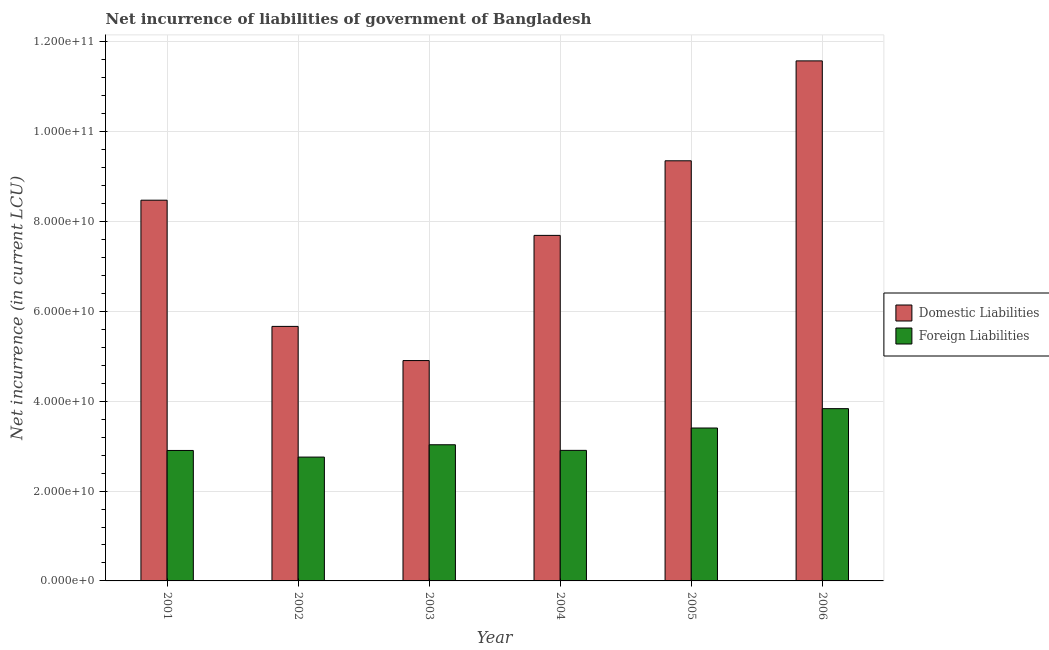How many different coloured bars are there?
Your answer should be compact. 2. How many bars are there on the 4th tick from the left?
Provide a short and direct response. 2. How many bars are there on the 4th tick from the right?
Ensure brevity in your answer.  2. What is the label of the 4th group of bars from the left?
Provide a short and direct response. 2004. In how many cases, is the number of bars for a given year not equal to the number of legend labels?
Keep it short and to the point. 0. What is the net incurrence of foreign liabilities in 2004?
Provide a succinct answer. 2.91e+1. Across all years, what is the maximum net incurrence of domestic liabilities?
Your answer should be compact. 1.16e+11. Across all years, what is the minimum net incurrence of domestic liabilities?
Give a very brief answer. 4.91e+1. What is the total net incurrence of foreign liabilities in the graph?
Offer a terse response. 1.88e+11. What is the difference between the net incurrence of foreign liabilities in 2002 and that in 2005?
Offer a very short reply. -6.47e+09. What is the difference between the net incurrence of domestic liabilities in 2001 and the net incurrence of foreign liabilities in 2006?
Make the answer very short. -3.10e+1. What is the average net incurrence of foreign liabilities per year?
Offer a very short reply. 3.14e+1. In how many years, is the net incurrence of domestic liabilities greater than 72000000000 LCU?
Provide a succinct answer. 4. What is the ratio of the net incurrence of foreign liabilities in 2002 to that in 2004?
Give a very brief answer. 0.95. Is the net incurrence of domestic liabilities in 2001 less than that in 2006?
Your answer should be very brief. Yes. What is the difference between the highest and the second highest net incurrence of foreign liabilities?
Provide a succinct answer. 4.31e+09. What is the difference between the highest and the lowest net incurrence of foreign liabilities?
Ensure brevity in your answer.  1.08e+1. What does the 1st bar from the left in 2001 represents?
Your answer should be very brief. Domestic Liabilities. What does the 2nd bar from the right in 2001 represents?
Make the answer very short. Domestic Liabilities. How many bars are there?
Offer a terse response. 12. Are the values on the major ticks of Y-axis written in scientific E-notation?
Provide a succinct answer. Yes. Does the graph contain any zero values?
Make the answer very short. No. How many legend labels are there?
Make the answer very short. 2. What is the title of the graph?
Your answer should be very brief. Net incurrence of liabilities of government of Bangladesh. Does "Mineral" appear as one of the legend labels in the graph?
Provide a short and direct response. No. What is the label or title of the Y-axis?
Keep it short and to the point. Net incurrence (in current LCU). What is the Net incurrence (in current LCU) of Domestic Liabilities in 2001?
Ensure brevity in your answer.  8.47e+1. What is the Net incurrence (in current LCU) of Foreign Liabilities in 2001?
Provide a short and direct response. 2.90e+1. What is the Net incurrence (in current LCU) in Domestic Liabilities in 2002?
Your answer should be compact. 5.67e+1. What is the Net incurrence (in current LCU) in Foreign Liabilities in 2002?
Provide a short and direct response. 2.76e+1. What is the Net incurrence (in current LCU) in Domestic Liabilities in 2003?
Your answer should be very brief. 4.91e+1. What is the Net incurrence (in current LCU) in Foreign Liabilities in 2003?
Your answer should be very brief. 3.03e+1. What is the Net incurrence (in current LCU) in Domestic Liabilities in 2004?
Your answer should be compact. 7.69e+1. What is the Net incurrence (in current LCU) of Foreign Liabilities in 2004?
Provide a short and direct response. 2.91e+1. What is the Net incurrence (in current LCU) in Domestic Liabilities in 2005?
Your answer should be compact. 9.35e+1. What is the Net incurrence (in current LCU) of Foreign Liabilities in 2005?
Offer a very short reply. 3.40e+1. What is the Net incurrence (in current LCU) in Domestic Liabilities in 2006?
Keep it short and to the point. 1.16e+11. What is the Net incurrence (in current LCU) in Foreign Liabilities in 2006?
Provide a short and direct response. 3.83e+1. Across all years, what is the maximum Net incurrence (in current LCU) in Domestic Liabilities?
Offer a very short reply. 1.16e+11. Across all years, what is the maximum Net incurrence (in current LCU) in Foreign Liabilities?
Your answer should be very brief. 3.83e+1. Across all years, what is the minimum Net incurrence (in current LCU) of Domestic Liabilities?
Provide a succinct answer. 4.91e+1. Across all years, what is the minimum Net incurrence (in current LCU) in Foreign Liabilities?
Your answer should be compact. 2.76e+1. What is the total Net incurrence (in current LCU) of Domestic Liabilities in the graph?
Ensure brevity in your answer.  4.77e+11. What is the total Net incurrence (in current LCU) in Foreign Liabilities in the graph?
Ensure brevity in your answer.  1.88e+11. What is the difference between the Net incurrence (in current LCU) in Domestic Liabilities in 2001 and that in 2002?
Keep it short and to the point. 2.81e+1. What is the difference between the Net incurrence (in current LCU) of Foreign Liabilities in 2001 and that in 2002?
Offer a very short reply. 1.47e+09. What is the difference between the Net incurrence (in current LCU) of Domestic Liabilities in 2001 and that in 2003?
Provide a short and direct response. 3.57e+1. What is the difference between the Net incurrence (in current LCU) in Foreign Liabilities in 2001 and that in 2003?
Provide a short and direct response. -1.27e+09. What is the difference between the Net incurrence (in current LCU) in Domestic Liabilities in 2001 and that in 2004?
Your answer should be very brief. 7.83e+09. What is the difference between the Net incurrence (in current LCU) of Foreign Liabilities in 2001 and that in 2004?
Your answer should be very brief. -2.12e+07. What is the difference between the Net incurrence (in current LCU) of Domestic Liabilities in 2001 and that in 2005?
Offer a very short reply. -8.77e+09. What is the difference between the Net incurrence (in current LCU) of Foreign Liabilities in 2001 and that in 2005?
Your answer should be very brief. -5.00e+09. What is the difference between the Net incurrence (in current LCU) of Domestic Liabilities in 2001 and that in 2006?
Give a very brief answer. -3.10e+1. What is the difference between the Net incurrence (in current LCU) in Foreign Liabilities in 2001 and that in 2006?
Ensure brevity in your answer.  -9.31e+09. What is the difference between the Net incurrence (in current LCU) of Domestic Liabilities in 2002 and that in 2003?
Offer a very short reply. 7.60e+09. What is the difference between the Net incurrence (in current LCU) in Foreign Liabilities in 2002 and that in 2003?
Offer a terse response. -2.74e+09. What is the difference between the Net incurrence (in current LCU) of Domestic Liabilities in 2002 and that in 2004?
Provide a succinct answer. -2.03e+1. What is the difference between the Net incurrence (in current LCU) of Foreign Liabilities in 2002 and that in 2004?
Your answer should be very brief. -1.49e+09. What is the difference between the Net incurrence (in current LCU) of Domestic Liabilities in 2002 and that in 2005?
Your response must be concise. -3.69e+1. What is the difference between the Net incurrence (in current LCU) of Foreign Liabilities in 2002 and that in 2005?
Keep it short and to the point. -6.47e+09. What is the difference between the Net incurrence (in current LCU) of Domestic Liabilities in 2002 and that in 2006?
Keep it short and to the point. -5.91e+1. What is the difference between the Net incurrence (in current LCU) of Foreign Liabilities in 2002 and that in 2006?
Offer a very short reply. -1.08e+1. What is the difference between the Net incurrence (in current LCU) in Domestic Liabilities in 2003 and that in 2004?
Make the answer very short. -2.79e+1. What is the difference between the Net incurrence (in current LCU) in Foreign Liabilities in 2003 and that in 2004?
Your answer should be compact. 1.25e+09. What is the difference between the Net incurrence (in current LCU) in Domestic Liabilities in 2003 and that in 2005?
Provide a short and direct response. -4.45e+1. What is the difference between the Net incurrence (in current LCU) of Foreign Liabilities in 2003 and that in 2005?
Ensure brevity in your answer.  -3.73e+09. What is the difference between the Net incurrence (in current LCU) of Domestic Liabilities in 2003 and that in 2006?
Your answer should be very brief. -6.67e+1. What is the difference between the Net incurrence (in current LCU) in Foreign Liabilities in 2003 and that in 2006?
Keep it short and to the point. -8.04e+09. What is the difference between the Net incurrence (in current LCU) of Domestic Liabilities in 2004 and that in 2005?
Keep it short and to the point. -1.66e+1. What is the difference between the Net incurrence (in current LCU) in Foreign Liabilities in 2004 and that in 2005?
Give a very brief answer. -4.98e+09. What is the difference between the Net incurrence (in current LCU) of Domestic Liabilities in 2004 and that in 2006?
Make the answer very short. -3.88e+1. What is the difference between the Net incurrence (in current LCU) of Foreign Liabilities in 2004 and that in 2006?
Keep it short and to the point. -9.29e+09. What is the difference between the Net incurrence (in current LCU) in Domestic Liabilities in 2005 and that in 2006?
Make the answer very short. -2.22e+1. What is the difference between the Net incurrence (in current LCU) in Foreign Liabilities in 2005 and that in 2006?
Give a very brief answer. -4.31e+09. What is the difference between the Net incurrence (in current LCU) in Domestic Liabilities in 2001 and the Net incurrence (in current LCU) in Foreign Liabilities in 2002?
Give a very brief answer. 5.72e+1. What is the difference between the Net incurrence (in current LCU) in Domestic Liabilities in 2001 and the Net incurrence (in current LCU) in Foreign Liabilities in 2003?
Ensure brevity in your answer.  5.44e+1. What is the difference between the Net incurrence (in current LCU) in Domestic Liabilities in 2001 and the Net incurrence (in current LCU) in Foreign Liabilities in 2004?
Your answer should be very brief. 5.57e+1. What is the difference between the Net incurrence (in current LCU) in Domestic Liabilities in 2001 and the Net incurrence (in current LCU) in Foreign Liabilities in 2005?
Offer a very short reply. 5.07e+1. What is the difference between the Net incurrence (in current LCU) of Domestic Liabilities in 2001 and the Net incurrence (in current LCU) of Foreign Liabilities in 2006?
Provide a succinct answer. 4.64e+1. What is the difference between the Net incurrence (in current LCU) of Domestic Liabilities in 2002 and the Net incurrence (in current LCU) of Foreign Liabilities in 2003?
Offer a very short reply. 2.63e+1. What is the difference between the Net incurrence (in current LCU) of Domestic Liabilities in 2002 and the Net incurrence (in current LCU) of Foreign Liabilities in 2004?
Give a very brief answer. 2.76e+1. What is the difference between the Net incurrence (in current LCU) in Domestic Liabilities in 2002 and the Net incurrence (in current LCU) in Foreign Liabilities in 2005?
Provide a short and direct response. 2.26e+1. What is the difference between the Net incurrence (in current LCU) of Domestic Liabilities in 2002 and the Net incurrence (in current LCU) of Foreign Liabilities in 2006?
Your response must be concise. 1.83e+1. What is the difference between the Net incurrence (in current LCU) in Domestic Liabilities in 2003 and the Net incurrence (in current LCU) in Foreign Liabilities in 2004?
Your answer should be very brief. 2.00e+1. What is the difference between the Net incurrence (in current LCU) in Domestic Liabilities in 2003 and the Net incurrence (in current LCU) in Foreign Liabilities in 2005?
Provide a succinct answer. 1.50e+1. What is the difference between the Net incurrence (in current LCU) in Domestic Liabilities in 2003 and the Net incurrence (in current LCU) in Foreign Liabilities in 2006?
Provide a succinct answer. 1.07e+1. What is the difference between the Net incurrence (in current LCU) of Domestic Liabilities in 2004 and the Net incurrence (in current LCU) of Foreign Liabilities in 2005?
Ensure brevity in your answer.  4.29e+1. What is the difference between the Net incurrence (in current LCU) of Domestic Liabilities in 2004 and the Net incurrence (in current LCU) of Foreign Liabilities in 2006?
Keep it short and to the point. 3.86e+1. What is the difference between the Net incurrence (in current LCU) in Domestic Liabilities in 2005 and the Net incurrence (in current LCU) in Foreign Liabilities in 2006?
Offer a very short reply. 5.52e+1. What is the average Net incurrence (in current LCU) of Domestic Liabilities per year?
Offer a terse response. 7.94e+1. What is the average Net incurrence (in current LCU) of Foreign Liabilities per year?
Your answer should be compact. 3.14e+1. In the year 2001, what is the difference between the Net incurrence (in current LCU) of Domestic Liabilities and Net incurrence (in current LCU) of Foreign Liabilities?
Your response must be concise. 5.57e+1. In the year 2002, what is the difference between the Net incurrence (in current LCU) of Domestic Liabilities and Net incurrence (in current LCU) of Foreign Liabilities?
Your answer should be very brief. 2.91e+1. In the year 2003, what is the difference between the Net incurrence (in current LCU) of Domestic Liabilities and Net incurrence (in current LCU) of Foreign Liabilities?
Your answer should be very brief. 1.87e+1. In the year 2004, what is the difference between the Net incurrence (in current LCU) in Domestic Liabilities and Net incurrence (in current LCU) in Foreign Liabilities?
Give a very brief answer. 4.79e+1. In the year 2005, what is the difference between the Net incurrence (in current LCU) in Domestic Liabilities and Net incurrence (in current LCU) in Foreign Liabilities?
Your answer should be compact. 5.95e+1. In the year 2006, what is the difference between the Net incurrence (in current LCU) in Domestic Liabilities and Net incurrence (in current LCU) in Foreign Liabilities?
Your answer should be very brief. 7.74e+1. What is the ratio of the Net incurrence (in current LCU) of Domestic Liabilities in 2001 to that in 2002?
Make the answer very short. 1.5. What is the ratio of the Net incurrence (in current LCU) in Foreign Liabilities in 2001 to that in 2002?
Offer a very short reply. 1.05. What is the ratio of the Net incurrence (in current LCU) of Domestic Liabilities in 2001 to that in 2003?
Your answer should be compact. 1.73. What is the ratio of the Net incurrence (in current LCU) in Foreign Liabilities in 2001 to that in 2003?
Ensure brevity in your answer.  0.96. What is the ratio of the Net incurrence (in current LCU) of Domestic Liabilities in 2001 to that in 2004?
Provide a succinct answer. 1.1. What is the ratio of the Net incurrence (in current LCU) of Foreign Liabilities in 2001 to that in 2004?
Offer a terse response. 1. What is the ratio of the Net incurrence (in current LCU) of Domestic Liabilities in 2001 to that in 2005?
Provide a succinct answer. 0.91. What is the ratio of the Net incurrence (in current LCU) in Foreign Liabilities in 2001 to that in 2005?
Your answer should be very brief. 0.85. What is the ratio of the Net incurrence (in current LCU) in Domestic Liabilities in 2001 to that in 2006?
Your answer should be very brief. 0.73. What is the ratio of the Net incurrence (in current LCU) in Foreign Liabilities in 2001 to that in 2006?
Your response must be concise. 0.76. What is the ratio of the Net incurrence (in current LCU) of Domestic Liabilities in 2002 to that in 2003?
Ensure brevity in your answer.  1.16. What is the ratio of the Net incurrence (in current LCU) in Foreign Liabilities in 2002 to that in 2003?
Give a very brief answer. 0.91. What is the ratio of the Net incurrence (in current LCU) in Domestic Liabilities in 2002 to that in 2004?
Offer a terse response. 0.74. What is the ratio of the Net incurrence (in current LCU) in Foreign Liabilities in 2002 to that in 2004?
Make the answer very short. 0.95. What is the ratio of the Net incurrence (in current LCU) of Domestic Liabilities in 2002 to that in 2005?
Make the answer very short. 0.61. What is the ratio of the Net incurrence (in current LCU) of Foreign Liabilities in 2002 to that in 2005?
Provide a short and direct response. 0.81. What is the ratio of the Net incurrence (in current LCU) of Domestic Liabilities in 2002 to that in 2006?
Offer a very short reply. 0.49. What is the ratio of the Net incurrence (in current LCU) of Foreign Liabilities in 2002 to that in 2006?
Give a very brief answer. 0.72. What is the ratio of the Net incurrence (in current LCU) of Domestic Liabilities in 2003 to that in 2004?
Make the answer very short. 0.64. What is the ratio of the Net incurrence (in current LCU) in Foreign Liabilities in 2003 to that in 2004?
Provide a short and direct response. 1.04. What is the ratio of the Net incurrence (in current LCU) of Domestic Liabilities in 2003 to that in 2005?
Offer a very short reply. 0.52. What is the ratio of the Net incurrence (in current LCU) in Foreign Liabilities in 2003 to that in 2005?
Your response must be concise. 0.89. What is the ratio of the Net incurrence (in current LCU) of Domestic Liabilities in 2003 to that in 2006?
Your response must be concise. 0.42. What is the ratio of the Net incurrence (in current LCU) of Foreign Liabilities in 2003 to that in 2006?
Make the answer very short. 0.79. What is the ratio of the Net incurrence (in current LCU) of Domestic Liabilities in 2004 to that in 2005?
Make the answer very short. 0.82. What is the ratio of the Net incurrence (in current LCU) of Foreign Liabilities in 2004 to that in 2005?
Your response must be concise. 0.85. What is the ratio of the Net incurrence (in current LCU) of Domestic Liabilities in 2004 to that in 2006?
Your answer should be very brief. 0.66. What is the ratio of the Net incurrence (in current LCU) of Foreign Liabilities in 2004 to that in 2006?
Your answer should be very brief. 0.76. What is the ratio of the Net incurrence (in current LCU) in Domestic Liabilities in 2005 to that in 2006?
Your answer should be very brief. 0.81. What is the ratio of the Net incurrence (in current LCU) in Foreign Liabilities in 2005 to that in 2006?
Give a very brief answer. 0.89. What is the difference between the highest and the second highest Net incurrence (in current LCU) of Domestic Liabilities?
Provide a short and direct response. 2.22e+1. What is the difference between the highest and the second highest Net incurrence (in current LCU) of Foreign Liabilities?
Offer a terse response. 4.31e+09. What is the difference between the highest and the lowest Net incurrence (in current LCU) in Domestic Liabilities?
Provide a succinct answer. 6.67e+1. What is the difference between the highest and the lowest Net incurrence (in current LCU) of Foreign Liabilities?
Offer a very short reply. 1.08e+1. 